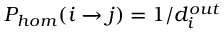Convert formula to latex. <formula><loc_0><loc_0><loc_500><loc_500>P _ { h o m } ( i j ) = 1 / d _ { i } ^ { o u t }</formula> 